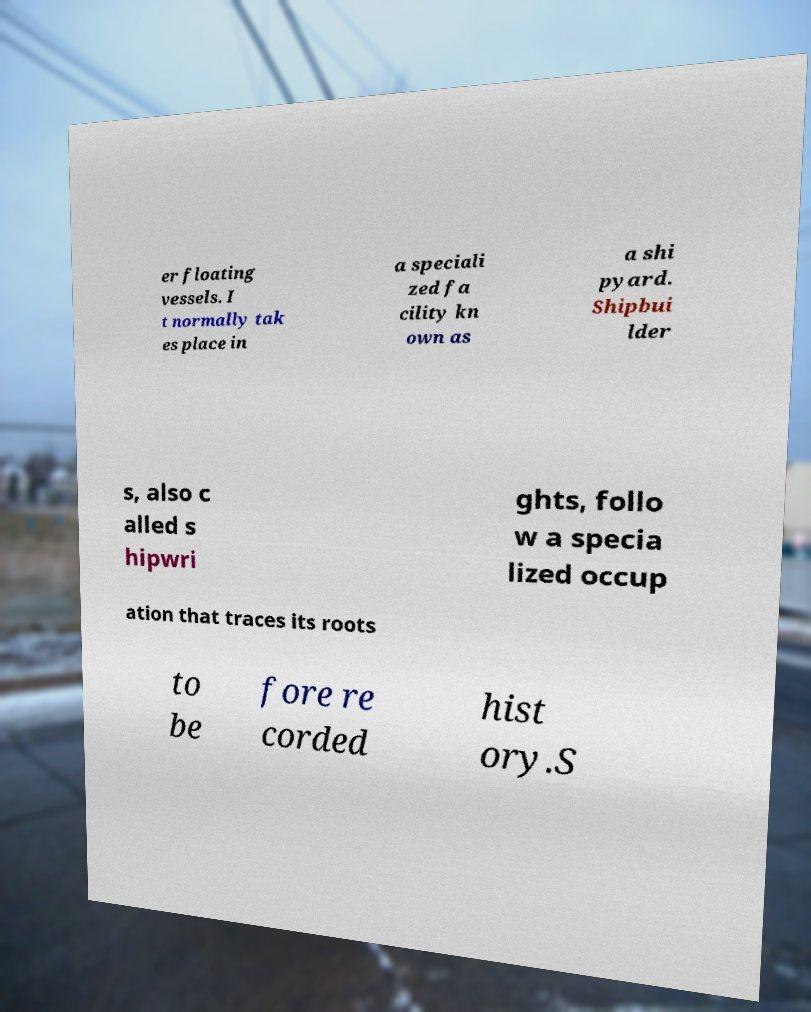Please identify and transcribe the text found in this image. er floating vessels. I t normally tak es place in a speciali zed fa cility kn own as a shi pyard. Shipbui lder s, also c alled s hipwri ghts, follo w a specia lized occup ation that traces its roots to be fore re corded hist ory.S 